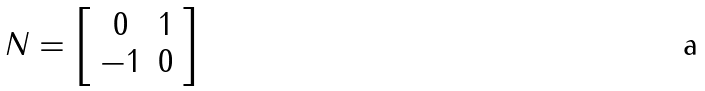<formula> <loc_0><loc_0><loc_500><loc_500>N = \left [ \begin{array} { c c } 0 & 1 \\ - 1 & 0 \end{array} \right ]</formula> 